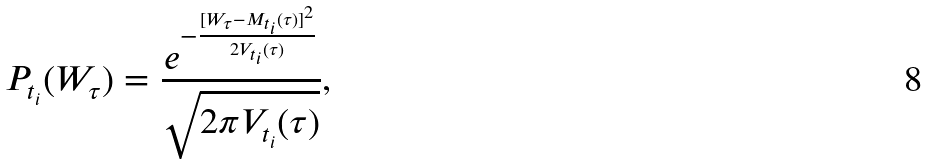Convert formula to latex. <formula><loc_0><loc_0><loc_500><loc_500>P _ { t _ { i } } ( W _ { \tau } ) = \frac { e ^ { - \frac { [ W _ { \tau } - M _ { t _ { i } } ( \tau ) ] ^ { 2 } } { 2 V _ { t _ { i } } ( \tau ) } } } { \sqrt { 2 \pi V _ { t _ { i } } ( \tau ) } } ,</formula> 